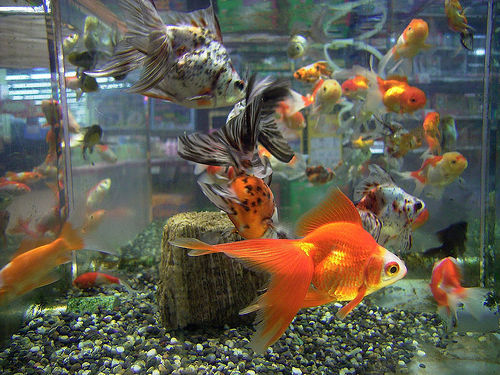<image>
Is there a fish in the water? Yes. The fish is contained within or inside the water, showing a containment relationship. 